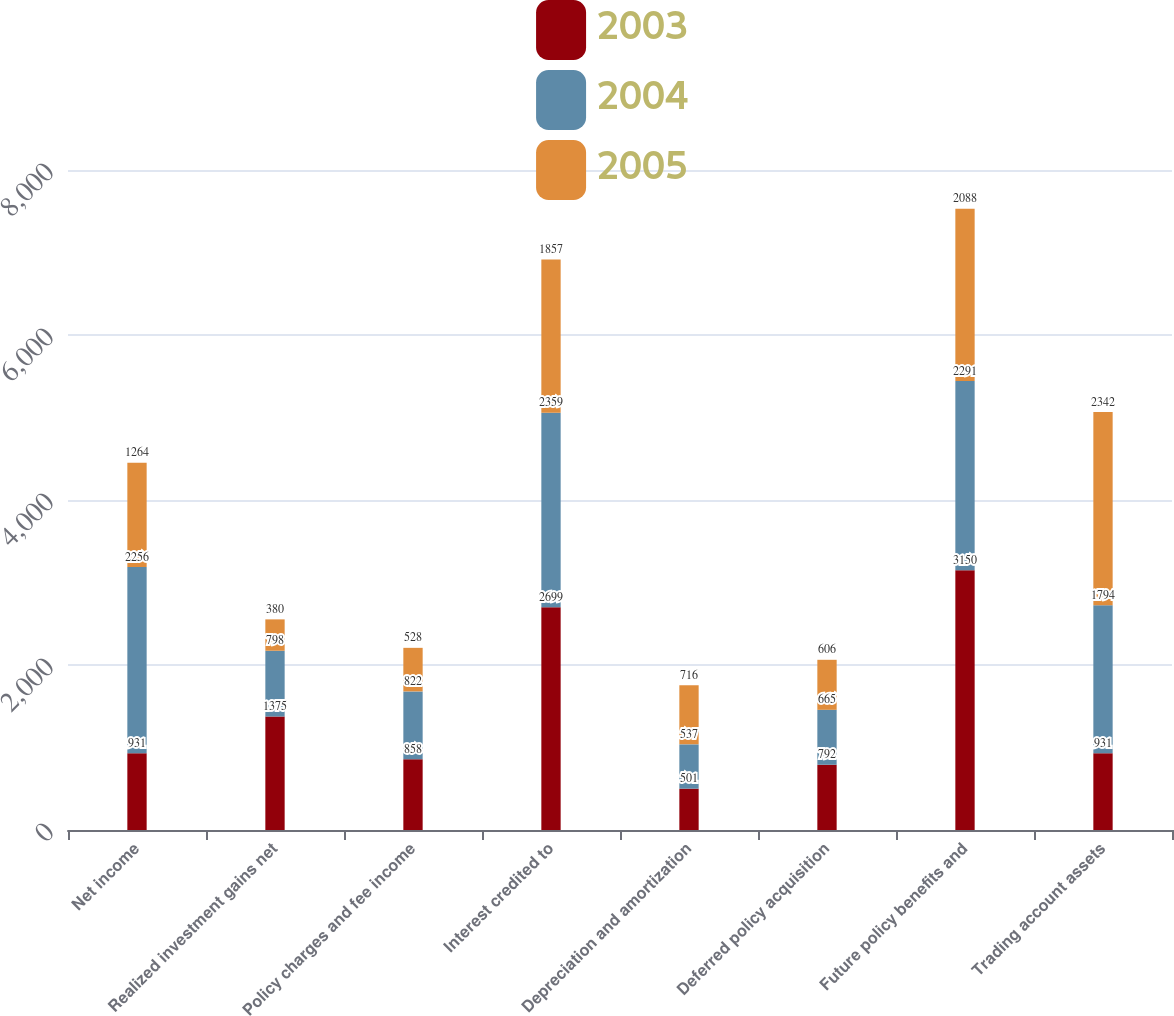Convert chart to OTSL. <chart><loc_0><loc_0><loc_500><loc_500><stacked_bar_chart><ecel><fcel>Net income<fcel>Realized investment gains net<fcel>Policy charges and fee income<fcel>Interest credited to<fcel>Depreciation and amortization<fcel>Deferred policy acquisition<fcel>Future policy benefits and<fcel>Trading account assets<nl><fcel>2003<fcel>931<fcel>1375<fcel>858<fcel>2699<fcel>501<fcel>792<fcel>3150<fcel>931<nl><fcel>2004<fcel>2256<fcel>798<fcel>822<fcel>2359<fcel>537<fcel>665<fcel>2291<fcel>1794<nl><fcel>2005<fcel>1264<fcel>380<fcel>528<fcel>1857<fcel>716<fcel>606<fcel>2088<fcel>2342<nl></chart> 